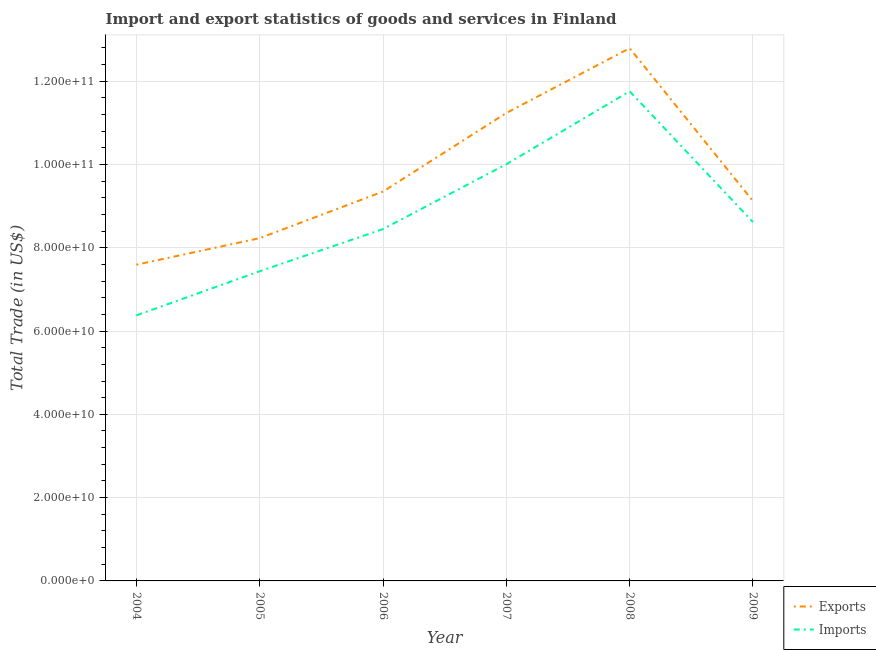How many different coloured lines are there?
Your answer should be very brief. 2. What is the imports of goods and services in 2005?
Make the answer very short. 7.44e+1. Across all years, what is the maximum export of goods and services?
Your answer should be very brief. 1.28e+11. Across all years, what is the minimum export of goods and services?
Your response must be concise. 7.59e+1. What is the total export of goods and services in the graph?
Ensure brevity in your answer.  5.83e+11. What is the difference between the export of goods and services in 2007 and that in 2009?
Your answer should be very brief. 2.11e+1. What is the difference between the export of goods and services in 2004 and the imports of goods and services in 2006?
Keep it short and to the point. -8.55e+09. What is the average export of goods and services per year?
Provide a succinct answer. 9.72e+1. In the year 2005, what is the difference between the export of goods and services and imports of goods and services?
Provide a short and direct response. 7.94e+09. What is the ratio of the imports of goods and services in 2007 to that in 2009?
Your response must be concise. 1.16. What is the difference between the highest and the second highest export of goods and services?
Offer a very short reply. 1.55e+1. What is the difference between the highest and the lowest imports of goods and services?
Ensure brevity in your answer.  5.38e+1. In how many years, is the export of goods and services greater than the average export of goods and services taken over all years?
Make the answer very short. 2. Is the export of goods and services strictly greater than the imports of goods and services over the years?
Provide a short and direct response. Yes. How many lines are there?
Give a very brief answer. 2. How many years are there in the graph?
Provide a short and direct response. 6. What is the difference between two consecutive major ticks on the Y-axis?
Give a very brief answer. 2.00e+1. Does the graph contain any zero values?
Provide a succinct answer. No. Where does the legend appear in the graph?
Your answer should be very brief. Bottom right. How many legend labels are there?
Your answer should be compact. 2. What is the title of the graph?
Offer a very short reply. Import and export statistics of goods and services in Finland. What is the label or title of the X-axis?
Your response must be concise. Year. What is the label or title of the Y-axis?
Keep it short and to the point. Total Trade (in US$). What is the Total Trade (in US$) in Exports in 2004?
Provide a short and direct response. 7.59e+1. What is the Total Trade (in US$) in Imports in 2004?
Your answer should be very brief. 6.38e+1. What is the Total Trade (in US$) of Exports in 2005?
Offer a very short reply. 8.23e+1. What is the Total Trade (in US$) in Imports in 2005?
Offer a very short reply. 7.44e+1. What is the Total Trade (in US$) of Exports in 2006?
Your response must be concise. 9.35e+1. What is the Total Trade (in US$) of Imports in 2006?
Make the answer very short. 8.45e+1. What is the Total Trade (in US$) in Exports in 2007?
Provide a short and direct response. 1.12e+11. What is the Total Trade (in US$) of Imports in 2007?
Your response must be concise. 1.00e+11. What is the Total Trade (in US$) in Exports in 2008?
Make the answer very short. 1.28e+11. What is the Total Trade (in US$) in Imports in 2008?
Provide a short and direct response. 1.18e+11. What is the Total Trade (in US$) of Exports in 2009?
Your answer should be very brief. 9.12e+1. What is the Total Trade (in US$) in Imports in 2009?
Offer a terse response. 8.62e+1. Across all years, what is the maximum Total Trade (in US$) in Exports?
Your answer should be very brief. 1.28e+11. Across all years, what is the maximum Total Trade (in US$) in Imports?
Your answer should be very brief. 1.18e+11. Across all years, what is the minimum Total Trade (in US$) in Exports?
Your response must be concise. 7.59e+1. Across all years, what is the minimum Total Trade (in US$) in Imports?
Your response must be concise. 6.38e+1. What is the total Total Trade (in US$) in Exports in the graph?
Your answer should be very brief. 5.83e+11. What is the total Total Trade (in US$) of Imports in the graph?
Keep it short and to the point. 5.26e+11. What is the difference between the Total Trade (in US$) of Exports in 2004 and that in 2005?
Make the answer very short. -6.37e+09. What is the difference between the Total Trade (in US$) in Imports in 2004 and that in 2005?
Your response must be concise. -1.06e+1. What is the difference between the Total Trade (in US$) of Exports in 2004 and that in 2006?
Ensure brevity in your answer.  -1.76e+1. What is the difference between the Total Trade (in US$) in Imports in 2004 and that in 2006?
Ensure brevity in your answer.  -2.07e+1. What is the difference between the Total Trade (in US$) in Exports in 2004 and that in 2007?
Your response must be concise. -3.64e+1. What is the difference between the Total Trade (in US$) in Imports in 2004 and that in 2007?
Keep it short and to the point. -3.63e+1. What is the difference between the Total Trade (in US$) in Exports in 2004 and that in 2008?
Give a very brief answer. -5.20e+1. What is the difference between the Total Trade (in US$) in Imports in 2004 and that in 2008?
Keep it short and to the point. -5.38e+1. What is the difference between the Total Trade (in US$) of Exports in 2004 and that in 2009?
Provide a short and direct response. -1.53e+1. What is the difference between the Total Trade (in US$) in Imports in 2004 and that in 2009?
Keep it short and to the point. -2.24e+1. What is the difference between the Total Trade (in US$) of Exports in 2005 and that in 2006?
Make the answer very short. -1.12e+1. What is the difference between the Total Trade (in US$) of Imports in 2005 and that in 2006?
Keep it short and to the point. -1.01e+1. What is the difference between the Total Trade (in US$) in Exports in 2005 and that in 2007?
Keep it short and to the point. -3.01e+1. What is the difference between the Total Trade (in US$) in Imports in 2005 and that in 2007?
Offer a terse response. -2.57e+1. What is the difference between the Total Trade (in US$) in Exports in 2005 and that in 2008?
Provide a succinct answer. -4.56e+1. What is the difference between the Total Trade (in US$) in Imports in 2005 and that in 2008?
Provide a short and direct response. -4.32e+1. What is the difference between the Total Trade (in US$) of Exports in 2005 and that in 2009?
Provide a succinct answer. -8.92e+09. What is the difference between the Total Trade (in US$) in Imports in 2005 and that in 2009?
Provide a short and direct response. -1.18e+1. What is the difference between the Total Trade (in US$) of Exports in 2006 and that in 2007?
Your response must be concise. -1.89e+1. What is the difference between the Total Trade (in US$) of Imports in 2006 and that in 2007?
Your answer should be compact. -1.56e+1. What is the difference between the Total Trade (in US$) of Exports in 2006 and that in 2008?
Provide a succinct answer. -3.44e+1. What is the difference between the Total Trade (in US$) in Imports in 2006 and that in 2008?
Provide a succinct answer. -3.31e+1. What is the difference between the Total Trade (in US$) of Exports in 2006 and that in 2009?
Offer a terse response. 2.27e+09. What is the difference between the Total Trade (in US$) in Imports in 2006 and that in 2009?
Keep it short and to the point. -1.68e+09. What is the difference between the Total Trade (in US$) in Exports in 2007 and that in 2008?
Keep it short and to the point. -1.55e+1. What is the difference between the Total Trade (in US$) in Imports in 2007 and that in 2008?
Offer a terse response. -1.75e+1. What is the difference between the Total Trade (in US$) in Exports in 2007 and that in 2009?
Make the answer very short. 2.11e+1. What is the difference between the Total Trade (in US$) in Imports in 2007 and that in 2009?
Keep it short and to the point. 1.39e+1. What is the difference between the Total Trade (in US$) of Exports in 2008 and that in 2009?
Make the answer very short. 3.67e+1. What is the difference between the Total Trade (in US$) of Imports in 2008 and that in 2009?
Keep it short and to the point. 3.14e+1. What is the difference between the Total Trade (in US$) in Exports in 2004 and the Total Trade (in US$) in Imports in 2005?
Offer a terse response. 1.57e+09. What is the difference between the Total Trade (in US$) of Exports in 2004 and the Total Trade (in US$) of Imports in 2006?
Provide a succinct answer. -8.55e+09. What is the difference between the Total Trade (in US$) in Exports in 2004 and the Total Trade (in US$) in Imports in 2007?
Keep it short and to the point. -2.41e+1. What is the difference between the Total Trade (in US$) of Exports in 2004 and the Total Trade (in US$) of Imports in 2008?
Your response must be concise. -4.16e+1. What is the difference between the Total Trade (in US$) of Exports in 2004 and the Total Trade (in US$) of Imports in 2009?
Give a very brief answer. -1.02e+1. What is the difference between the Total Trade (in US$) of Exports in 2005 and the Total Trade (in US$) of Imports in 2006?
Offer a very short reply. -2.18e+09. What is the difference between the Total Trade (in US$) in Exports in 2005 and the Total Trade (in US$) in Imports in 2007?
Offer a terse response. -1.78e+1. What is the difference between the Total Trade (in US$) of Exports in 2005 and the Total Trade (in US$) of Imports in 2008?
Provide a succinct answer. -3.53e+1. What is the difference between the Total Trade (in US$) in Exports in 2005 and the Total Trade (in US$) in Imports in 2009?
Offer a very short reply. -3.87e+09. What is the difference between the Total Trade (in US$) in Exports in 2006 and the Total Trade (in US$) in Imports in 2007?
Give a very brief answer. -6.57e+09. What is the difference between the Total Trade (in US$) of Exports in 2006 and the Total Trade (in US$) of Imports in 2008?
Provide a short and direct response. -2.41e+1. What is the difference between the Total Trade (in US$) of Exports in 2006 and the Total Trade (in US$) of Imports in 2009?
Offer a very short reply. 7.32e+09. What is the difference between the Total Trade (in US$) of Exports in 2007 and the Total Trade (in US$) of Imports in 2008?
Offer a very short reply. -5.20e+09. What is the difference between the Total Trade (in US$) of Exports in 2007 and the Total Trade (in US$) of Imports in 2009?
Make the answer very short. 2.62e+1. What is the difference between the Total Trade (in US$) of Exports in 2008 and the Total Trade (in US$) of Imports in 2009?
Offer a terse response. 4.17e+1. What is the average Total Trade (in US$) of Exports per year?
Your answer should be compact. 9.72e+1. What is the average Total Trade (in US$) of Imports per year?
Offer a terse response. 8.77e+1. In the year 2004, what is the difference between the Total Trade (in US$) in Exports and Total Trade (in US$) in Imports?
Offer a very short reply. 1.22e+1. In the year 2005, what is the difference between the Total Trade (in US$) in Exports and Total Trade (in US$) in Imports?
Provide a succinct answer. 7.94e+09. In the year 2006, what is the difference between the Total Trade (in US$) of Exports and Total Trade (in US$) of Imports?
Provide a succinct answer. 9.01e+09. In the year 2007, what is the difference between the Total Trade (in US$) of Exports and Total Trade (in US$) of Imports?
Your response must be concise. 1.23e+1. In the year 2008, what is the difference between the Total Trade (in US$) of Exports and Total Trade (in US$) of Imports?
Provide a short and direct response. 1.03e+1. In the year 2009, what is the difference between the Total Trade (in US$) of Exports and Total Trade (in US$) of Imports?
Make the answer very short. 5.06e+09. What is the ratio of the Total Trade (in US$) in Exports in 2004 to that in 2005?
Offer a very short reply. 0.92. What is the ratio of the Total Trade (in US$) of Imports in 2004 to that in 2005?
Your response must be concise. 0.86. What is the ratio of the Total Trade (in US$) in Exports in 2004 to that in 2006?
Provide a succinct answer. 0.81. What is the ratio of the Total Trade (in US$) in Imports in 2004 to that in 2006?
Your answer should be compact. 0.75. What is the ratio of the Total Trade (in US$) of Exports in 2004 to that in 2007?
Your answer should be compact. 0.68. What is the ratio of the Total Trade (in US$) in Imports in 2004 to that in 2007?
Offer a very short reply. 0.64. What is the ratio of the Total Trade (in US$) in Exports in 2004 to that in 2008?
Provide a succinct answer. 0.59. What is the ratio of the Total Trade (in US$) in Imports in 2004 to that in 2008?
Your response must be concise. 0.54. What is the ratio of the Total Trade (in US$) in Exports in 2004 to that in 2009?
Keep it short and to the point. 0.83. What is the ratio of the Total Trade (in US$) of Imports in 2004 to that in 2009?
Provide a short and direct response. 0.74. What is the ratio of the Total Trade (in US$) in Exports in 2005 to that in 2006?
Your answer should be compact. 0.88. What is the ratio of the Total Trade (in US$) in Imports in 2005 to that in 2006?
Keep it short and to the point. 0.88. What is the ratio of the Total Trade (in US$) of Exports in 2005 to that in 2007?
Ensure brevity in your answer.  0.73. What is the ratio of the Total Trade (in US$) in Imports in 2005 to that in 2007?
Give a very brief answer. 0.74. What is the ratio of the Total Trade (in US$) in Exports in 2005 to that in 2008?
Keep it short and to the point. 0.64. What is the ratio of the Total Trade (in US$) of Imports in 2005 to that in 2008?
Your answer should be compact. 0.63. What is the ratio of the Total Trade (in US$) of Exports in 2005 to that in 2009?
Provide a succinct answer. 0.9. What is the ratio of the Total Trade (in US$) in Imports in 2005 to that in 2009?
Give a very brief answer. 0.86. What is the ratio of the Total Trade (in US$) of Exports in 2006 to that in 2007?
Make the answer very short. 0.83. What is the ratio of the Total Trade (in US$) of Imports in 2006 to that in 2007?
Your answer should be compact. 0.84. What is the ratio of the Total Trade (in US$) in Exports in 2006 to that in 2008?
Give a very brief answer. 0.73. What is the ratio of the Total Trade (in US$) in Imports in 2006 to that in 2008?
Your response must be concise. 0.72. What is the ratio of the Total Trade (in US$) in Exports in 2006 to that in 2009?
Your response must be concise. 1.02. What is the ratio of the Total Trade (in US$) in Imports in 2006 to that in 2009?
Your answer should be very brief. 0.98. What is the ratio of the Total Trade (in US$) of Exports in 2007 to that in 2008?
Your response must be concise. 0.88. What is the ratio of the Total Trade (in US$) in Imports in 2007 to that in 2008?
Offer a terse response. 0.85. What is the ratio of the Total Trade (in US$) of Exports in 2007 to that in 2009?
Make the answer very short. 1.23. What is the ratio of the Total Trade (in US$) of Imports in 2007 to that in 2009?
Provide a succinct answer. 1.16. What is the ratio of the Total Trade (in US$) in Exports in 2008 to that in 2009?
Offer a very short reply. 1.4. What is the ratio of the Total Trade (in US$) of Imports in 2008 to that in 2009?
Ensure brevity in your answer.  1.36. What is the difference between the highest and the second highest Total Trade (in US$) of Exports?
Provide a short and direct response. 1.55e+1. What is the difference between the highest and the second highest Total Trade (in US$) of Imports?
Provide a succinct answer. 1.75e+1. What is the difference between the highest and the lowest Total Trade (in US$) in Exports?
Ensure brevity in your answer.  5.20e+1. What is the difference between the highest and the lowest Total Trade (in US$) of Imports?
Offer a terse response. 5.38e+1. 